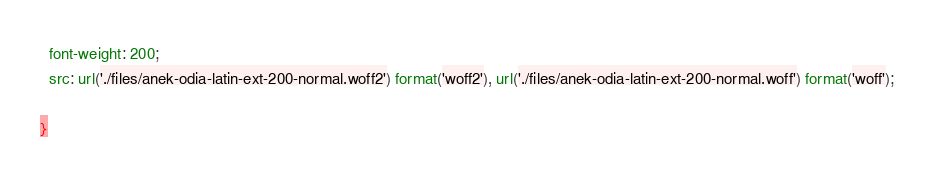Convert code to text. <code><loc_0><loc_0><loc_500><loc_500><_CSS_>  font-weight: 200;
  src: url('./files/anek-odia-latin-ext-200-normal.woff2') format('woff2'), url('./files/anek-odia-latin-ext-200-normal.woff') format('woff');
  
}
</code> 